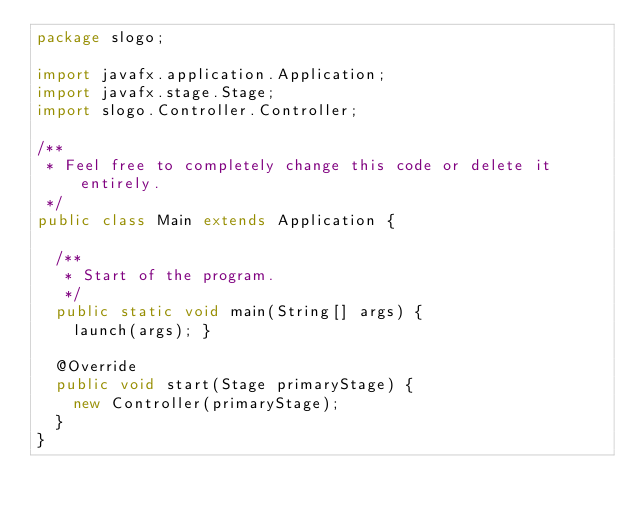<code> <loc_0><loc_0><loc_500><loc_500><_Java_>package slogo;

import javafx.application.Application;
import javafx.stage.Stage;
import slogo.Controller.Controller;

/**
 * Feel free to completely change this code or delete it entirely.
 */
public class Main extends Application {

  /**
   * Start of the program.
   */
  public static void main(String[] args) {
    launch(args); }

  @Override
  public void start(Stage primaryStage) {
    new Controller(primaryStage);
  }
}
</code> 